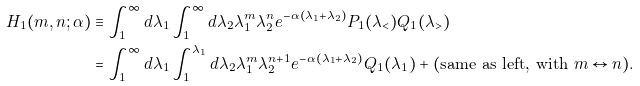Convert formula to latex. <formula><loc_0><loc_0><loc_500><loc_500>H _ { 1 } ( m , n ; \alpha ) & \equiv \int ^ { \infty } _ { 1 } d \lambda _ { 1 } \int ^ { \infty } _ { 1 } d \lambda _ { 2 } \lambda _ { 1 } ^ { m } \lambda _ { 2 } ^ { n } e ^ { - \alpha ( \lambda _ { 1 } + \lambda _ { 2 } ) } P _ { 1 } ( \lambda _ { < } ) Q _ { 1 } ( \lambda _ { > } ) \\ & = \int ^ { \infty } _ { 1 } d \lambda _ { 1 } \int ^ { \lambda _ { 1 } } _ { 1 } d \lambda _ { 2 } \lambda _ { 1 } ^ { m } \lambda _ { 2 } ^ { n + 1 } e ^ { - \alpha ( \lambda _ { 1 } + \lambda _ { 2 } ) } Q _ { 1 } ( \lambda _ { 1 } ) + ( \text {same as left, with } m \leftrightarrow n ) .</formula> 